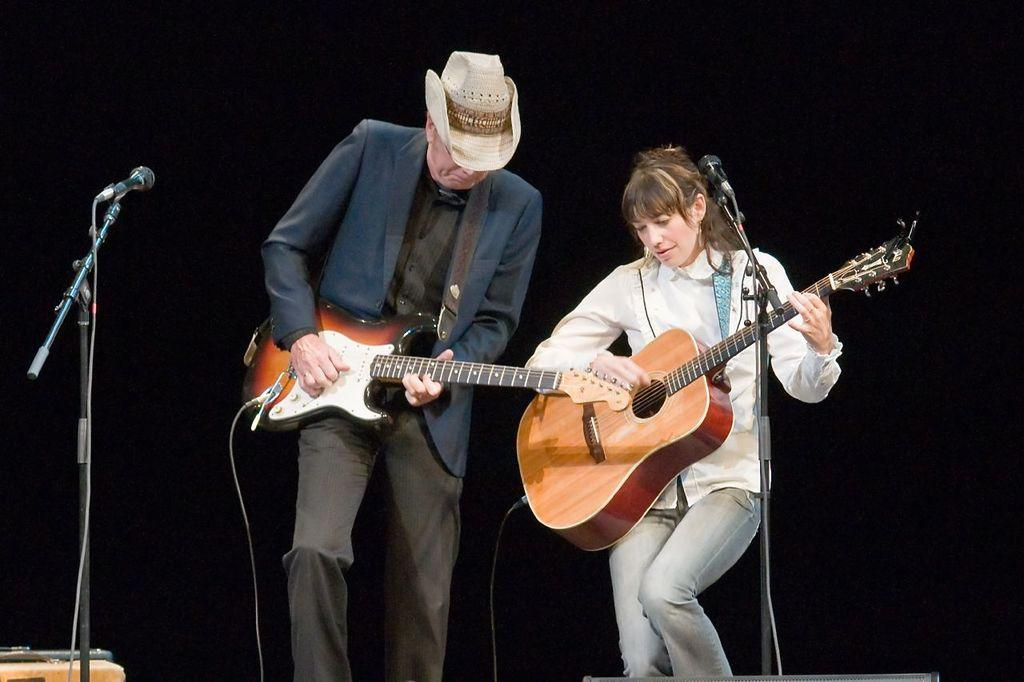How many people are in the image? There are 2 people in the image. What are the people doing in the image? The people are standing and playing guitar. Can you describe the positioning of the microphones in the image? There is a microphone on the left side of the image and another on the right side of the image. What is the person on the left side of the image wearing? The person on the left is wearing a suit and a hat. How many giants are present in the image? There are no giants present in the image; it features two people playing guitar. What type of knowledge is being shared between the two people in the image? The image does not provide any information about the knowledge being shared between the two people; they are simply playing guitar. 